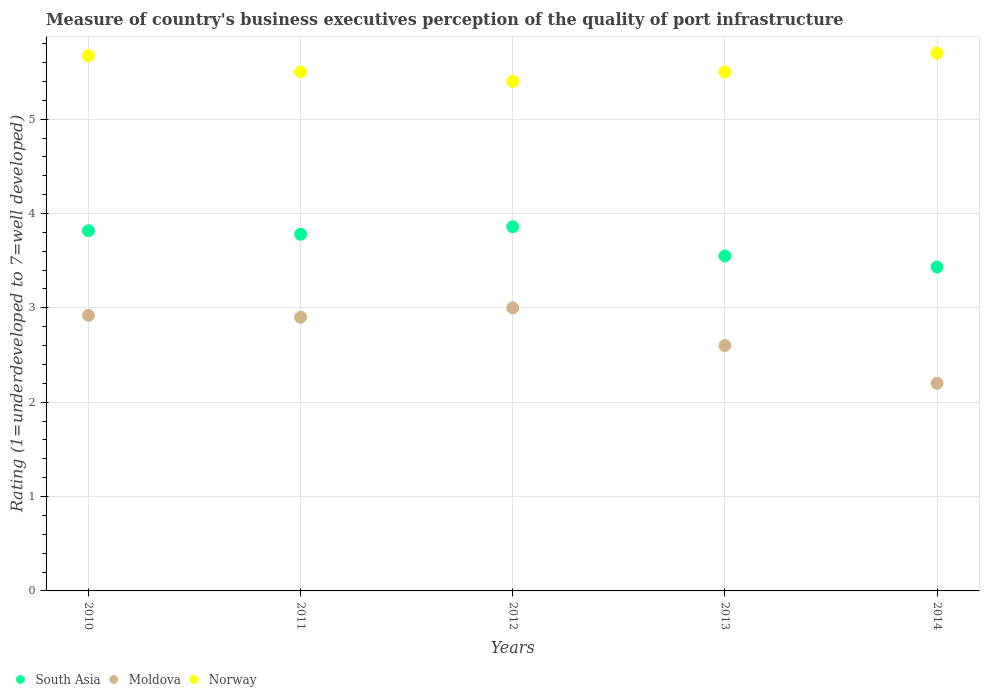How many different coloured dotlines are there?
Your answer should be very brief. 3. What is the ratings of the quality of port infrastructure in South Asia in 2012?
Make the answer very short. 3.86. Across all years, what is the maximum ratings of the quality of port infrastructure in South Asia?
Offer a very short reply. 3.86. Across all years, what is the minimum ratings of the quality of port infrastructure in South Asia?
Your answer should be very brief. 3.43. In which year was the ratings of the quality of port infrastructure in Norway maximum?
Your response must be concise. 2014. In which year was the ratings of the quality of port infrastructure in South Asia minimum?
Your answer should be very brief. 2014. What is the total ratings of the quality of port infrastructure in Moldova in the graph?
Give a very brief answer. 13.62. What is the difference between the ratings of the quality of port infrastructure in South Asia in 2012 and that in 2014?
Provide a succinct answer. 0.43. What is the difference between the ratings of the quality of port infrastructure in South Asia in 2014 and the ratings of the quality of port infrastructure in Moldova in 2012?
Ensure brevity in your answer.  0.43. What is the average ratings of the quality of port infrastructure in South Asia per year?
Provide a short and direct response. 3.69. In the year 2012, what is the difference between the ratings of the quality of port infrastructure in Moldova and ratings of the quality of port infrastructure in Norway?
Provide a short and direct response. -2.4. In how many years, is the ratings of the quality of port infrastructure in Moldova greater than 3.4?
Provide a short and direct response. 0. What is the ratio of the ratings of the quality of port infrastructure in South Asia in 2010 to that in 2011?
Give a very brief answer. 1.01. Is the ratings of the quality of port infrastructure in Moldova in 2011 less than that in 2013?
Your response must be concise. No. Is the difference between the ratings of the quality of port infrastructure in Moldova in 2012 and 2014 greater than the difference between the ratings of the quality of port infrastructure in Norway in 2012 and 2014?
Keep it short and to the point. Yes. What is the difference between the highest and the second highest ratings of the quality of port infrastructure in South Asia?
Your answer should be very brief. 0.04. What is the difference between the highest and the lowest ratings of the quality of port infrastructure in Norway?
Make the answer very short. 0.3. Is the ratings of the quality of port infrastructure in South Asia strictly less than the ratings of the quality of port infrastructure in Moldova over the years?
Ensure brevity in your answer.  No. How many legend labels are there?
Your response must be concise. 3. What is the title of the graph?
Your response must be concise. Measure of country's business executives perception of the quality of port infrastructure. Does "Papua New Guinea" appear as one of the legend labels in the graph?
Provide a succinct answer. No. What is the label or title of the Y-axis?
Keep it short and to the point. Rating (1=underdeveloped to 7=well developed). What is the Rating (1=underdeveloped to 7=well developed) in South Asia in 2010?
Your answer should be very brief. 3.82. What is the Rating (1=underdeveloped to 7=well developed) of Moldova in 2010?
Offer a terse response. 2.92. What is the Rating (1=underdeveloped to 7=well developed) in Norway in 2010?
Give a very brief answer. 5.67. What is the Rating (1=underdeveloped to 7=well developed) in South Asia in 2011?
Offer a terse response. 3.78. What is the Rating (1=underdeveloped to 7=well developed) in Moldova in 2011?
Provide a succinct answer. 2.9. What is the Rating (1=underdeveloped to 7=well developed) of Norway in 2011?
Make the answer very short. 5.5. What is the Rating (1=underdeveloped to 7=well developed) in South Asia in 2012?
Offer a very short reply. 3.86. What is the Rating (1=underdeveloped to 7=well developed) of South Asia in 2013?
Your answer should be compact. 3.55. What is the Rating (1=underdeveloped to 7=well developed) of Moldova in 2013?
Offer a terse response. 2.6. What is the Rating (1=underdeveloped to 7=well developed) in South Asia in 2014?
Your response must be concise. 3.43. What is the Rating (1=underdeveloped to 7=well developed) of Moldova in 2014?
Offer a very short reply. 2.2. Across all years, what is the maximum Rating (1=underdeveloped to 7=well developed) of South Asia?
Offer a terse response. 3.86. Across all years, what is the maximum Rating (1=underdeveloped to 7=well developed) of Moldova?
Make the answer very short. 3. Across all years, what is the maximum Rating (1=underdeveloped to 7=well developed) in Norway?
Your answer should be very brief. 5.7. Across all years, what is the minimum Rating (1=underdeveloped to 7=well developed) in South Asia?
Your answer should be compact. 3.43. Across all years, what is the minimum Rating (1=underdeveloped to 7=well developed) in Moldova?
Keep it short and to the point. 2.2. Across all years, what is the minimum Rating (1=underdeveloped to 7=well developed) of Norway?
Provide a succinct answer. 5.4. What is the total Rating (1=underdeveloped to 7=well developed) of South Asia in the graph?
Your answer should be very brief. 18.44. What is the total Rating (1=underdeveloped to 7=well developed) in Moldova in the graph?
Give a very brief answer. 13.62. What is the total Rating (1=underdeveloped to 7=well developed) of Norway in the graph?
Make the answer very short. 27.77. What is the difference between the Rating (1=underdeveloped to 7=well developed) in South Asia in 2010 and that in 2011?
Make the answer very short. 0.04. What is the difference between the Rating (1=underdeveloped to 7=well developed) in Moldova in 2010 and that in 2011?
Your response must be concise. 0.02. What is the difference between the Rating (1=underdeveloped to 7=well developed) of Norway in 2010 and that in 2011?
Offer a terse response. 0.17. What is the difference between the Rating (1=underdeveloped to 7=well developed) of South Asia in 2010 and that in 2012?
Provide a succinct answer. -0.04. What is the difference between the Rating (1=underdeveloped to 7=well developed) of Moldova in 2010 and that in 2012?
Offer a very short reply. -0.08. What is the difference between the Rating (1=underdeveloped to 7=well developed) of Norway in 2010 and that in 2012?
Keep it short and to the point. 0.27. What is the difference between the Rating (1=underdeveloped to 7=well developed) of South Asia in 2010 and that in 2013?
Offer a very short reply. 0.27. What is the difference between the Rating (1=underdeveloped to 7=well developed) in Moldova in 2010 and that in 2013?
Ensure brevity in your answer.  0.32. What is the difference between the Rating (1=underdeveloped to 7=well developed) in Norway in 2010 and that in 2013?
Provide a short and direct response. 0.17. What is the difference between the Rating (1=underdeveloped to 7=well developed) in South Asia in 2010 and that in 2014?
Provide a short and direct response. 0.38. What is the difference between the Rating (1=underdeveloped to 7=well developed) in Moldova in 2010 and that in 2014?
Offer a terse response. 0.72. What is the difference between the Rating (1=underdeveloped to 7=well developed) of Norway in 2010 and that in 2014?
Keep it short and to the point. -0.03. What is the difference between the Rating (1=underdeveloped to 7=well developed) in South Asia in 2011 and that in 2012?
Make the answer very short. -0.08. What is the difference between the Rating (1=underdeveloped to 7=well developed) in South Asia in 2011 and that in 2013?
Offer a terse response. 0.23. What is the difference between the Rating (1=underdeveloped to 7=well developed) of Moldova in 2011 and that in 2013?
Offer a terse response. 0.3. What is the difference between the Rating (1=underdeveloped to 7=well developed) of Norway in 2011 and that in 2013?
Your answer should be compact. 0. What is the difference between the Rating (1=underdeveloped to 7=well developed) of South Asia in 2011 and that in 2014?
Make the answer very short. 0.35. What is the difference between the Rating (1=underdeveloped to 7=well developed) of South Asia in 2012 and that in 2013?
Provide a short and direct response. 0.31. What is the difference between the Rating (1=underdeveloped to 7=well developed) in Norway in 2012 and that in 2013?
Provide a short and direct response. -0.1. What is the difference between the Rating (1=underdeveloped to 7=well developed) of South Asia in 2012 and that in 2014?
Provide a short and direct response. 0.43. What is the difference between the Rating (1=underdeveloped to 7=well developed) in Moldova in 2012 and that in 2014?
Provide a short and direct response. 0.8. What is the difference between the Rating (1=underdeveloped to 7=well developed) in South Asia in 2013 and that in 2014?
Make the answer very short. 0.12. What is the difference between the Rating (1=underdeveloped to 7=well developed) of South Asia in 2010 and the Rating (1=underdeveloped to 7=well developed) of Moldova in 2011?
Your answer should be very brief. 0.92. What is the difference between the Rating (1=underdeveloped to 7=well developed) in South Asia in 2010 and the Rating (1=underdeveloped to 7=well developed) in Norway in 2011?
Your answer should be compact. -1.68. What is the difference between the Rating (1=underdeveloped to 7=well developed) in Moldova in 2010 and the Rating (1=underdeveloped to 7=well developed) in Norway in 2011?
Provide a short and direct response. -2.58. What is the difference between the Rating (1=underdeveloped to 7=well developed) of South Asia in 2010 and the Rating (1=underdeveloped to 7=well developed) of Moldova in 2012?
Keep it short and to the point. 0.82. What is the difference between the Rating (1=underdeveloped to 7=well developed) of South Asia in 2010 and the Rating (1=underdeveloped to 7=well developed) of Norway in 2012?
Offer a terse response. -1.58. What is the difference between the Rating (1=underdeveloped to 7=well developed) of Moldova in 2010 and the Rating (1=underdeveloped to 7=well developed) of Norway in 2012?
Make the answer very short. -2.48. What is the difference between the Rating (1=underdeveloped to 7=well developed) of South Asia in 2010 and the Rating (1=underdeveloped to 7=well developed) of Moldova in 2013?
Offer a very short reply. 1.22. What is the difference between the Rating (1=underdeveloped to 7=well developed) of South Asia in 2010 and the Rating (1=underdeveloped to 7=well developed) of Norway in 2013?
Provide a succinct answer. -1.68. What is the difference between the Rating (1=underdeveloped to 7=well developed) in Moldova in 2010 and the Rating (1=underdeveloped to 7=well developed) in Norway in 2013?
Your answer should be very brief. -2.58. What is the difference between the Rating (1=underdeveloped to 7=well developed) of South Asia in 2010 and the Rating (1=underdeveloped to 7=well developed) of Moldova in 2014?
Keep it short and to the point. 1.62. What is the difference between the Rating (1=underdeveloped to 7=well developed) in South Asia in 2010 and the Rating (1=underdeveloped to 7=well developed) in Norway in 2014?
Keep it short and to the point. -1.88. What is the difference between the Rating (1=underdeveloped to 7=well developed) in Moldova in 2010 and the Rating (1=underdeveloped to 7=well developed) in Norway in 2014?
Your response must be concise. -2.78. What is the difference between the Rating (1=underdeveloped to 7=well developed) of South Asia in 2011 and the Rating (1=underdeveloped to 7=well developed) of Moldova in 2012?
Ensure brevity in your answer.  0.78. What is the difference between the Rating (1=underdeveloped to 7=well developed) in South Asia in 2011 and the Rating (1=underdeveloped to 7=well developed) in Norway in 2012?
Offer a very short reply. -1.62. What is the difference between the Rating (1=underdeveloped to 7=well developed) of Moldova in 2011 and the Rating (1=underdeveloped to 7=well developed) of Norway in 2012?
Offer a very short reply. -2.5. What is the difference between the Rating (1=underdeveloped to 7=well developed) in South Asia in 2011 and the Rating (1=underdeveloped to 7=well developed) in Moldova in 2013?
Provide a succinct answer. 1.18. What is the difference between the Rating (1=underdeveloped to 7=well developed) of South Asia in 2011 and the Rating (1=underdeveloped to 7=well developed) of Norway in 2013?
Give a very brief answer. -1.72. What is the difference between the Rating (1=underdeveloped to 7=well developed) in South Asia in 2011 and the Rating (1=underdeveloped to 7=well developed) in Moldova in 2014?
Your response must be concise. 1.58. What is the difference between the Rating (1=underdeveloped to 7=well developed) of South Asia in 2011 and the Rating (1=underdeveloped to 7=well developed) of Norway in 2014?
Offer a very short reply. -1.92. What is the difference between the Rating (1=underdeveloped to 7=well developed) of South Asia in 2012 and the Rating (1=underdeveloped to 7=well developed) of Moldova in 2013?
Offer a terse response. 1.26. What is the difference between the Rating (1=underdeveloped to 7=well developed) in South Asia in 2012 and the Rating (1=underdeveloped to 7=well developed) in Norway in 2013?
Give a very brief answer. -1.64. What is the difference between the Rating (1=underdeveloped to 7=well developed) in South Asia in 2012 and the Rating (1=underdeveloped to 7=well developed) in Moldova in 2014?
Your answer should be compact. 1.66. What is the difference between the Rating (1=underdeveloped to 7=well developed) of South Asia in 2012 and the Rating (1=underdeveloped to 7=well developed) of Norway in 2014?
Your response must be concise. -1.84. What is the difference between the Rating (1=underdeveloped to 7=well developed) of Moldova in 2012 and the Rating (1=underdeveloped to 7=well developed) of Norway in 2014?
Your answer should be very brief. -2.7. What is the difference between the Rating (1=underdeveloped to 7=well developed) in South Asia in 2013 and the Rating (1=underdeveloped to 7=well developed) in Moldova in 2014?
Offer a very short reply. 1.35. What is the difference between the Rating (1=underdeveloped to 7=well developed) in South Asia in 2013 and the Rating (1=underdeveloped to 7=well developed) in Norway in 2014?
Keep it short and to the point. -2.15. What is the difference between the Rating (1=underdeveloped to 7=well developed) in Moldova in 2013 and the Rating (1=underdeveloped to 7=well developed) in Norway in 2014?
Give a very brief answer. -3.1. What is the average Rating (1=underdeveloped to 7=well developed) of South Asia per year?
Your answer should be compact. 3.69. What is the average Rating (1=underdeveloped to 7=well developed) in Moldova per year?
Offer a very short reply. 2.72. What is the average Rating (1=underdeveloped to 7=well developed) in Norway per year?
Make the answer very short. 5.55. In the year 2010, what is the difference between the Rating (1=underdeveloped to 7=well developed) in South Asia and Rating (1=underdeveloped to 7=well developed) in Moldova?
Ensure brevity in your answer.  0.9. In the year 2010, what is the difference between the Rating (1=underdeveloped to 7=well developed) of South Asia and Rating (1=underdeveloped to 7=well developed) of Norway?
Give a very brief answer. -1.85. In the year 2010, what is the difference between the Rating (1=underdeveloped to 7=well developed) in Moldova and Rating (1=underdeveloped to 7=well developed) in Norway?
Keep it short and to the point. -2.75. In the year 2011, what is the difference between the Rating (1=underdeveloped to 7=well developed) of South Asia and Rating (1=underdeveloped to 7=well developed) of Norway?
Your answer should be very brief. -1.72. In the year 2012, what is the difference between the Rating (1=underdeveloped to 7=well developed) of South Asia and Rating (1=underdeveloped to 7=well developed) of Moldova?
Offer a very short reply. 0.86. In the year 2012, what is the difference between the Rating (1=underdeveloped to 7=well developed) in South Asia and Rating (1=underdeveloped to 7=well developed) in Norway?
Make the answer very short. -1.54. In the year 2012, what is the difference between the Rating (1=underdeveloped to 7=well developed) in Moldova and Rating (1=underdeveloped to 7=well developed) in Norway?
Your response must be concise. -2.4. In the year 2013, what is the difference between the Rating (1=underdeveloped to 7=well developed) of South Asia and Rating (1=underdeveloped to 7=well developed) of Norway?
Your response must be concise. -1.95. In the year 2013, what is the difference between the Rating (1=underdeveloped to 7=well developed) in Moldova and Rating (1=underdeveloped to 7=well developed) in Norway?
Provide a succinct answer. -2.9. In the year 2014, what is the difference between the Rating (1=underdeveloped to 7=well developed) in South Asia and Rating (1=underdeveloped to 7=well developed) in Moldova?
Your response must be concise. 1.23. In the year 2014, what is the difference between the Rating (1=underdeveloped to 7=well developed) of South Asia and Rating (1=underdeveloped to 7=well developed) of Norway?
Make the answer very short. -2.27. What is the ratio of the Rating (1=underdeveloped to 7=well developed) in South Asia in 2010 to that in 2011?
Your answer should be very brief. 1.01. What is the ratio of the Rating (1=underdeveloped to 7=well developed) in Moldova in 2010 to that in 2011?
Provide a short and direct response. 1.01. What is the ratio of the Rating (1=underdeveloped to 7=well developed) of Norway in 2010 to that in 2011?
Your answer should be very brief. 1.03. What is the ratio of the Rating (1=underdeveloped to 7=well developed) in Moldova in 2010 to that in 2012?
Offer a very short reply. 0.97. What is the ratio of the Rating (1=underdeveloped to 7=well developed) in Norway in 2010 to that in 2012?
Provide a short and direct response. 1.05. What is the ratio of the Rating (1=underdeveloped to 7=well developed) in South Asia in 2010 to that in 2013?
Give a very brief answer. 1.08. What is the ratio of the Rating (1=underdeveloped to 7=well developed) in Moldova in 2010 to that in 2013?
Make the answer very short. 1.12. What is the ratio of the Rating (1=underdeveloped to 7=well developed) in Norway in 2010 to that in 2013?
Keep it short and to the point. 1.03. What is the ratio of the Rating (1=underdeveloped to 7=well developed) in South Asia in 2010 to that in 2014?
Your answer should be very brief. 1.11. What is the ratio of the Rating (1=underdeveloped to 7=well developed) in Moldova in 2010 to that in 2014?
Offer a very short reply. 1.33. What is the ratio of the Rating (1=underdeveloped to 7=well developed) in South Asia in 2011 to that in 2012?
Provide a succinct answer. 0.98. What is the ratio of the Rating (1=underdeveloped to 7=well developed) in Moldova in 2011 to that in 2012?
Make the answer very short. 0.97. What is the ratio of the Rating (1=underdeveloped to 7=well developed) of Norway in 2011 to that in 2012?
Your answer should be very brief. 1.02. What is the ratio of the Rating (1=underdeveloped to 7=well developed) of South Asia in 2011 to that in 2013?
Provide a short and direct response. 1.06. What is the ratio of the Rating (1=underdeveloped to 7=well developed) in Moldova in 2011 to that in 2013?
Provide a succinct answer. 1.12. What is the ratio of the Rating (1=underdeveloped to 7=well developed) of South Asia in 2011 to that in 2014?
Offer a very short reply. 1.1. What is the ratio of the Rating (1=underdeveloped to 7=well developed) in Moldova in 2011 to that in 2014?
Offer a terse response. 1.32. What is the ratio of the Rating (1=underdeveloped to 7=well developed) of Norway in 2011 to that in 2014?
Keep it short and to the point. 0.96. What is the ratio of the Rating (1=underdeveloped to 7=well developed) in South Asia in 2012 to that in 2013?
Offer a terse response. 1.09. What is the ratio of the Rating (1=underdeveloped to 7=well developed) in Moldova in 2012 to that in 2013?
Offer a very short reply. 1.15. What is the ratio of the Rating (1=underdeveloped to 7=well developed) in Norway in 2012 to that in 2013?
Your answer should be compact. 0.98. What is the ratio of the Rating (1=underdeveloped to 7=well developed) of South Asia in 2012 to that in 2014?
Offer a very short reply. 1.12. What is the ratio of the Rating (1=underdeveloped to 7=well developed) of Moldova in 2012 to that in 2014?
Offer a terse response. 1.36. What is the ratio of the Rating (1=underdeveloped to 7=well developed) in South Asia in 2013 to that in 2014?
Provide a succinct answer. 1.03. What is the ratio of the Rating (1=underdeveloped to 7=well developed) of Moldova in 2013 to that in 2014?
Your response must be concise. 1.18. What is the ratio of the Rating (1=underdeveloped to 7=well developed) of Norway in 2013 to that in 2014?
Give a very brief answer. 0.96. What is the difference between the highest and the second highest Rating (1=underdeveloped to 7=well developed) in South Asia?
Your answer should be compact. 0.04. What is the difference between the highest and the second highest Rating (1=underdeveloped to 7=well developed) of Moldova?
Your response must be concise. 0.08. What is the difference between the highest and the second highest Rating (1=underdeveloped to 7=well developed) in Norway?
Your answer should be very brief. 0.03. What is the difference between the highest and the lowest Rating (1=underdeveloped to 7=well developed) of South Asia?
Give a very brief answer. 0.43. 